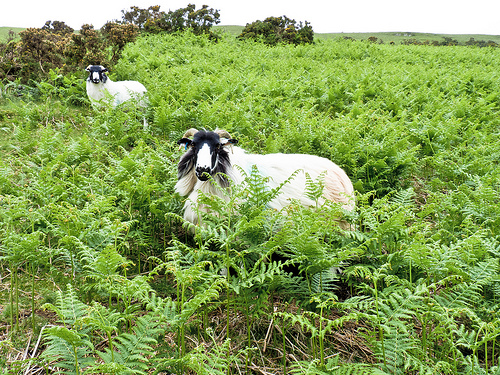Please provide a short description for this region: [0.43, 0.4, 0.63, 0.6]. The image focuses sharply on a goat with pristine white fur, highlighted against the darker, richer green of the surrounding ferns. 